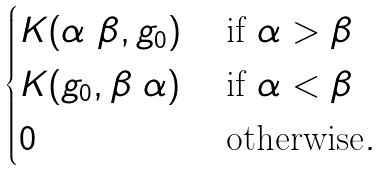Convert formula to latex. <formula><loc_0><loc_0><loc_500><loc_500>\begin{cases} K ( \alpha \ \beta , g _ { 0 } ) & \text { if } \alpha > \beta \\ K ( g _ { 0 } , \beta \ \alpha ) & \text { if } \alpha < \beta \\ 0 \quad & \text { otherwise} . \end{cases}</formula> 